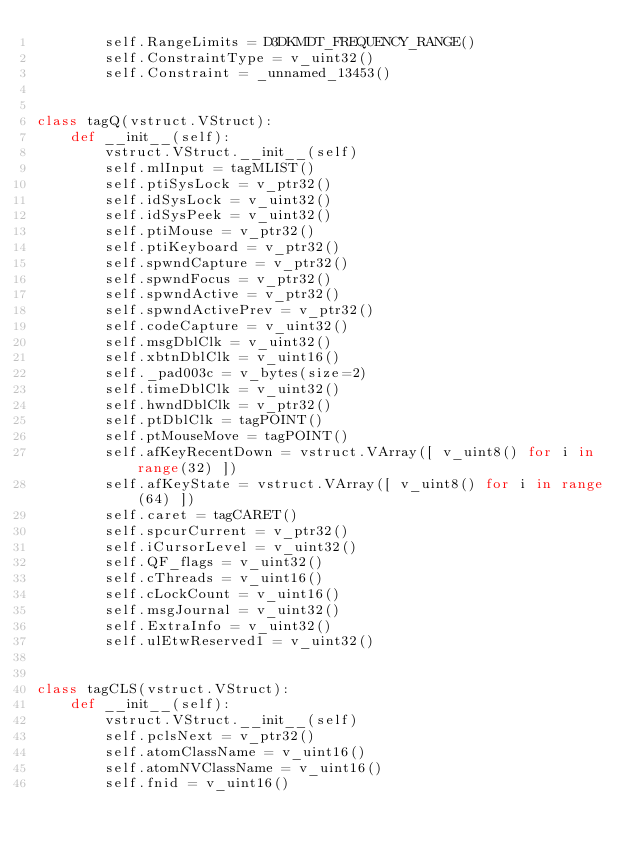<code> <loc_0><loc_0><loc_500><loc_500><_Python_>        self.RangeLimits = D3DKMDT_FREQUENCY_RANGE()
        self.ConstraintType = v_uint32()
        self.Constraint = _unnamed_13453()


class tagQ(vstruct.VStruct):
    def __init__(self):
        vstruct.VStruct.__init__(self)
        self.mlInput = tagMLIST()
        self.ptiSysLock = v_ptr32()
        self.idSysLock = v_uint32()
        self.idSysPeek = v_uint32()
        self.ptiMouse = v_ptr32()
        self.ptiKeyboard = v_ptr32()
        self.spwndCapture = v_ptr32()
        self.spwndFocus = v_ptr32()
        self.spwndActive = v_ptr32()
        self.spwndActivePrev = v_ptr32()
        self.codeCapture = v_uint32()
        self.msgDblClk = v_uint32()
        self.xbtnDblClk = v_uint16()
        self._pad003c = v_bytes(size=2)
        self.timeDblClk = v_uint32()
        self.hwndDblClk = v_ptr32()
        self.ptDblClk = tagPOINT()
        self.ptMouseMove = tagPOINT()
        self.afKeyRecentDown = vstruct.VArray([ v_uint8() for i in range(32) ])
        self.afKeyState = vstruct.VArray([ v_uint8() for i in range(64) ])
        self.caret = tagCARET()
        self.spcurCurrent = v_ptr32()
        self.iCursorLevel = v_uint32()
        self.QF_flags = v_uint32()
        self.cThreads = v_uint16()
        self.cLockCount = v_uint16()
        self.msgJournal = v_uint32()
        self.ExtraInfo = v_uint32()
        self.ulEtwReserved1 = v_uint32()


class tagCLS(vstruct.VStruct):
    def __init__(self):
        vstruct.VStruct.__init__(self)
        self.pclsNext = v_ptr32()
        self.atomClassName = v_uint16()
        self.atomNVClassName = v_uint16()
        self.fnid = v_uint16()</code> 